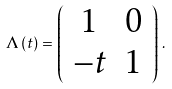<formula> <loc_0><loc_0><loc_500><loc_500>\Lambda \, ( t ) = \left ( \begin{array} { c l c r } 1 & 0 \\ - t & 1 \end{array} \right ) \, .</formula> 